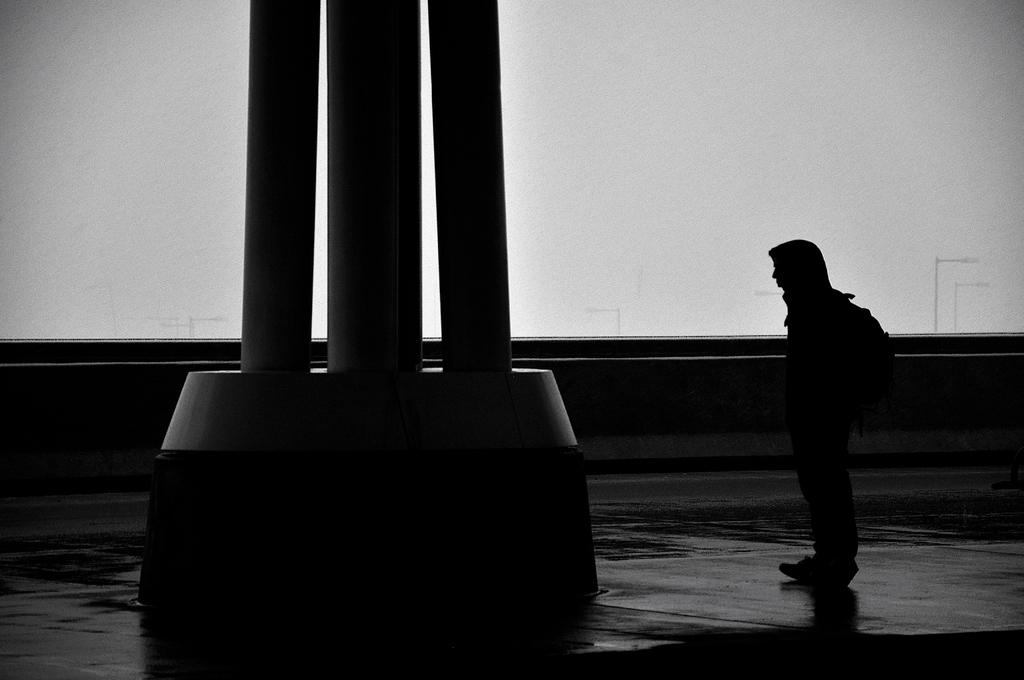What is the person doing on the right side of the image? There is a person standing on the right side of the image. What can be seen on the left side of the image? There is a construction on the left side of the image. What is visible in the background of the image? There are street lights and a wall in the background of the image. What type of volleyball game is being played by the person's friends in the image? There is no volleyball game or friends present in the image. 